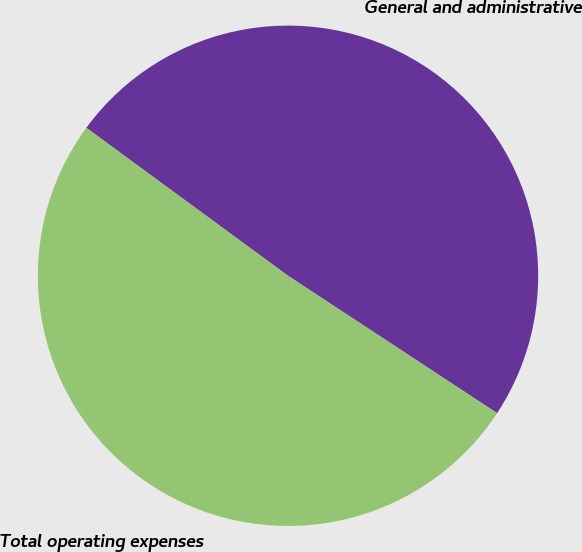Convert chart. <chart><loc_0><loc_0><loc_500><loc_500><pie_chart><fcel>General and administrative<fcel>Total operating expenses<nl><fcel>49.18%<fcel>50.82%<nl></chart> 